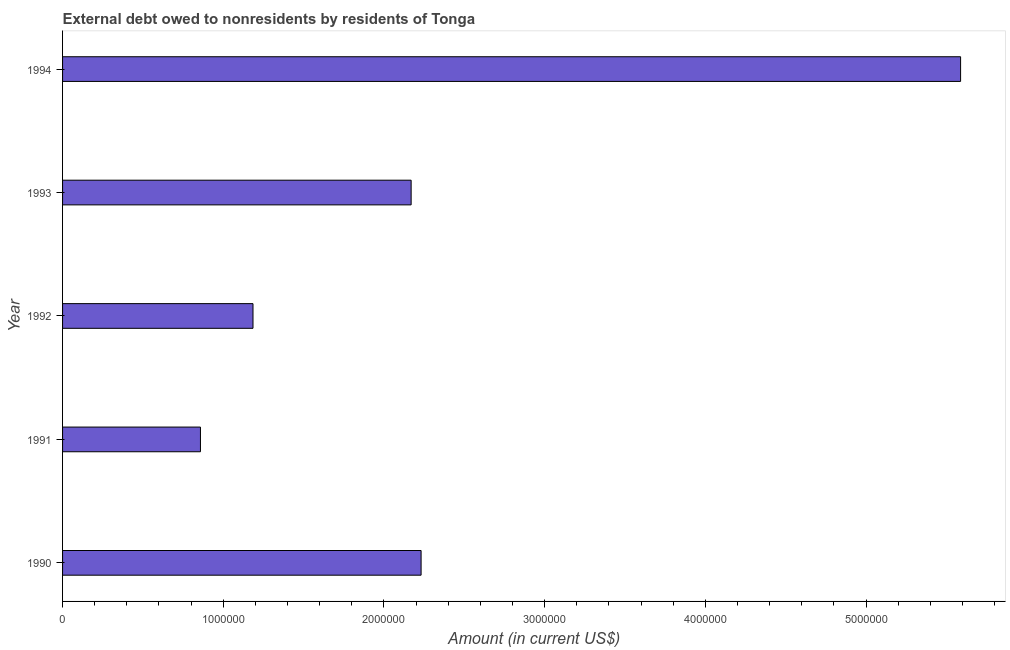Does the graph contain any zero values?
Provide a succinct answer. No. What is the title of the graph?
Provide a succinct answer. External debt owed to nonresidents by residents of Tonga. What is the label or title of the Y-axis?
Give a very brief answer. Year. What is the debt in 1994?
Provide a short and direct response. 5.59e+06. Across all years, what is the maximum debt?
Give a very brief answer. 5.59e+06. Across all years, what is the minimum debt?
Offer a very short reply. 8.58e+05. In which year was the debt maximum?
Give a very brief answer. 1994. What is the sum of the debt?
Make the answer very short. 1.20e+07. What is the difference between the debt in 1990 and 1991?
Your answer should be very brief. 1.37e+06. What is the average debt per year?
Offer a terse response. 2.41e+06. What is the median debt?
Keep it short and to the point. 2.17e+06. In how many years, is the debt greater than 2800000 US$?
Your answer should be very brief. 1. Do a majority of the years between 1991 and 1992 (inclusive) have debt greater than 3800000 US$?
Offer a very short reply. No. What is the ratio of the debt in 1990 to that in 1994?
Your answer should be compact. 0.4. What is the difference between the highest and the second highest debt?
Provide a short and direct response. 3.36e+06. Is the sum of the debt in 1990 and 1993 greater than the maximum debt across all years?
Provide a short and direct response. No. What is the difference between the highest and the lowest debt?
Your answer should be compact. 4.73e+06. In how many years, is the debt greater than the average debt taken over all years?
Your response must be concise. 1. What is the difference between two consecutive major ticks on the X-axis?
Your answer should be compact. 1.00e+06. What is the Amount (in current US$) of 1990?
Give a very brief answer. 2.23e+06. What is the Amount (in current US$) in 1991?
Provide a succinct answer. 8.58e+05. What is the Amount (in current US$) of 1992?
Ensure brevity in your answer.  1.18e+06. What is the Amount (in current US$) in 1993?
Give a very brief answer. 2.17e+06. What is the Amount (in current US$) of 1994?
Provide a short and direct response. 5.59e+06. What is the difference between the Amount (in current US$) in 1990 and 1991?
Ensure brevity in your answer.  1.37e+06. What is the difference between the Amount (in current US$) in 1990 and 1992?
Offer a terse response. 1.05e+06. What is the difference between the Amount (in current US$) in 1990 and 1993?
Make the answer very short. 6.20e+04. What is the difference between the Amount (in current US$) in 1990 and 1994?
Keep it short and to the point. -3.36e+06. What is the difference between the Amount (in current US$) in 1991 and 1992?
Make the answer very short. -3.27e+05. What is the difference between the Amount (in current US$) in 1991 and 1993?
Your response must be concise. -1.31e+06. What is the difference between the Amount (in current US$) in 1991 and 1994?
Give a very brief answer. -4.73e+06. What is the difference between the Amount (in current US$) in 1992 and 1993?
Give a very brief answer. -9.84e+05. What is the difference between the Amount (in current US$) in 1992 and 1994?
Provide a succinct answer. -4.40e+06. What is the difference between the Amount (in current US$) in 1993 and 1994?
Give a very brief answer. -3.42e+06. What is the ratio of the Amount (in current US$) in 1990 to that in 1992?
Your answer should be compact. 1.88. What is the ratio of the Amount (in current US$) in 1990 to that in 1994?
Provide a succinct answer. 0.4. What is the ratio of the Amount (in current US$) in 1991 to that in 1992?
Provide a short and direct response. 0.72. What is the ratio of the Amount (in current US$) in 1991 to that in 1993?
Your response must be concise. 0.4. What is the ratio of the Amount (in current US$) in 1991 to that in 1994?
Your answer should be very brief. 0.15. What is the ratio of the Amount (in current US$) in 1992 to that in 1993?
Your answer should be very brief. 0.55. What is the ratio of the Amount (in current US$) in 1992 to that in 1994?
Provide a succinct answer. 0.21. What is the ratio of the Amount (in current US$) in 1993 to that in 1994?
Provide a short and direct response. 0.39. 